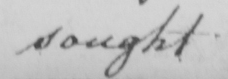What text is written in this handwritten line? sought 